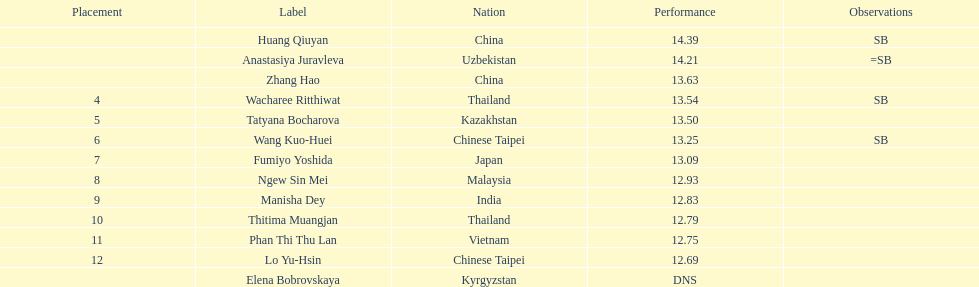How many people were ranked? 12. 